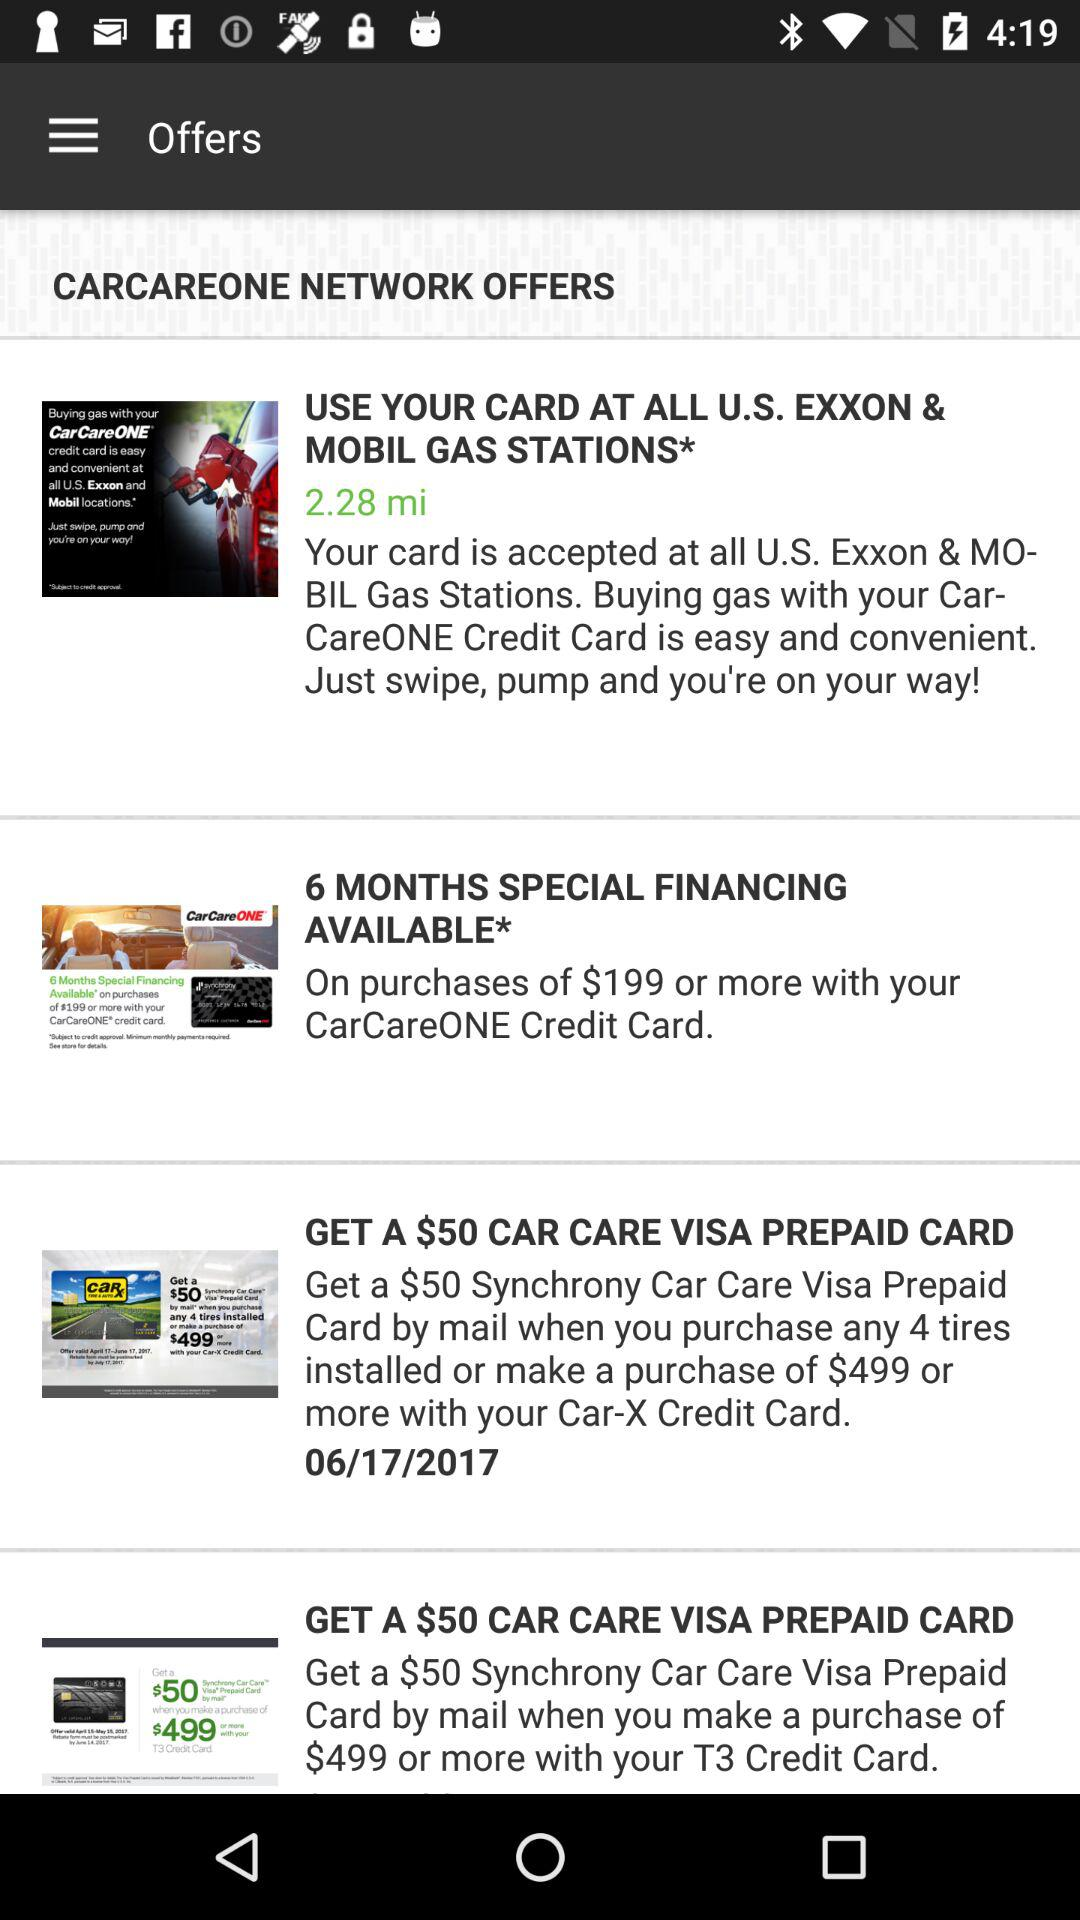How many offers are available to the user?
Answer the question using a single word or phrase. 4 